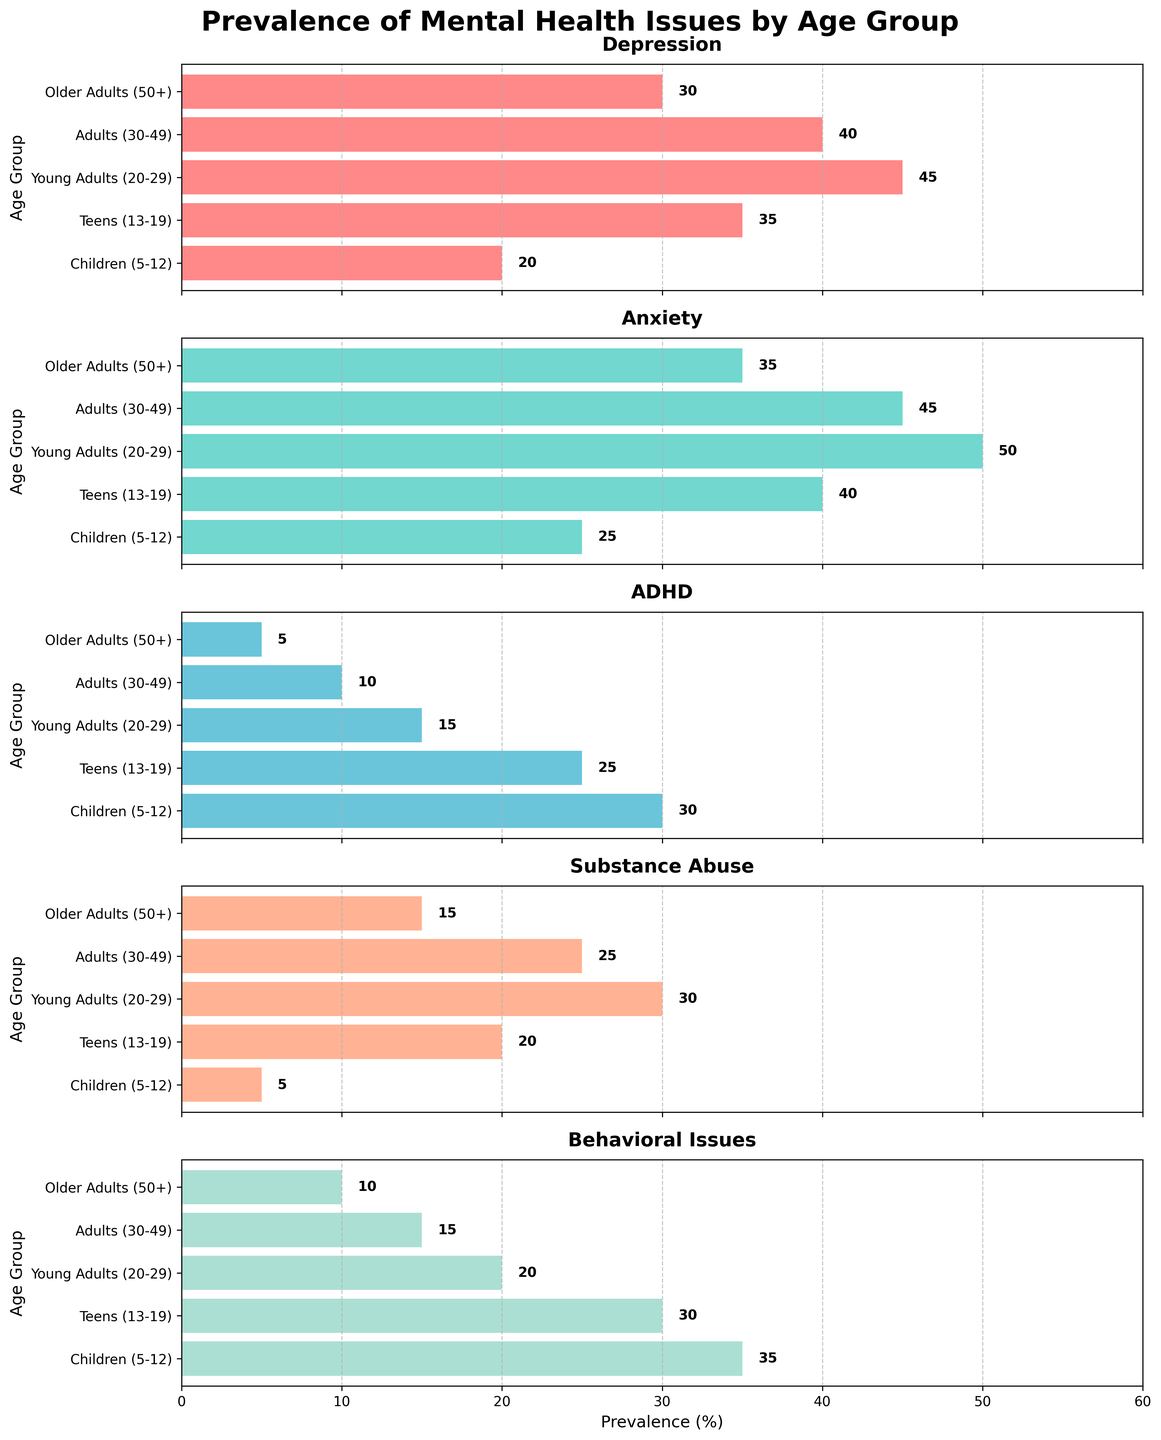What age group shows the highest prevalence of depression? According to the horizontal plot for Depression, Young Adults (20-29) have the longest bar, indicating the highest percentage of 45%.
Answer: Young Adults (20-29) What is the title of the figure? The title is displayed at the top center of the figure and reads "Prevalence of Mental Health Issues by Age Group".
Answer: Prevalence of Mental Health Issues by Age Group Compare the prevalence of ADHD between Teens and Older Adults. The bar for Teens in the ADHD plot is at 25%, while the Older Adults bar is at 5%. Thus, Teens have a higher prevalence.
Answer: Teens (13-19) Which mental health issue has the lowest prevalence in Older Adults? By looking at each subplot for Older Adults, Substance Abuse has the lowest bar at 15%.
Answer: Substance Abuse Which age group has consistently low prevalence across all issues? By reviewing each subplot, Older Adults (50+) have relatively low bars compared to other age groups across all issues.
Answer: Older Adults (50+) What is the difference in anxiety prevalence between Young Adults and Children? Young Adults have 50% prevalence for Anxiety, while Children have 25%. The difference is 50% - 25% = 25%.
Answer: 25% Which age group has the highest prevalence of behavioral issues? The Behavioral Issues subplot shows that Children (5-12) have the longest bar at 35%.
Answer: Children (5-12) What is the combined prevalence of depression and anxiety in Adults (30-49)? Adults (30-49) have a prevalence of 40% for Depression and 45% for Anxiety. The combined prevalence is 40% + 45% = 85%.
Answer: 85% What element is shown along the x-axis of each subplot? All subplots share the same x-axis, which represents the prevalence percentage from 0 to 60.
Answer: Prevalence (%) Which age group sees the highest variation across different mental health issues? By observing the length differences of the bars across subplots, Young Adults (20-29) show the highest variation with Depression at 45% and ADHD at 15%.
Answer: Young Adults (20-29) 